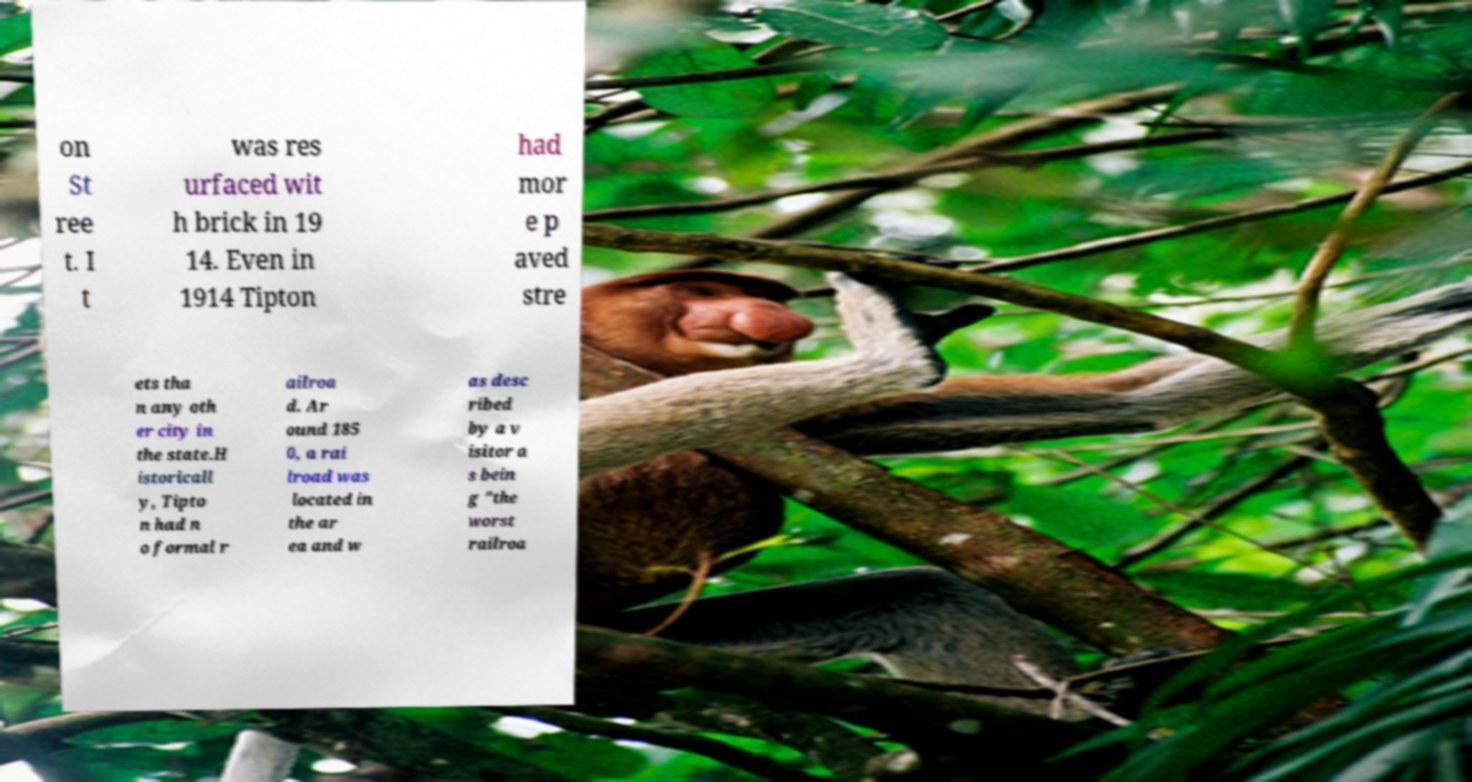For documentation purposes, I need the text within this image transcribed. Could you provide that? on St ree t. I t was res urfaced wit h brick in 19 14. Even in 1914 Tipton had mor e p aved stre ets tha n any oth er city in the state.H istoricall y, Tipto n had n o formal r ailroa d. Ar ound 185 0, a rai lroad was located in the ar ea and w as desc ribed by a v isitor a s bein g "the worst railroa 